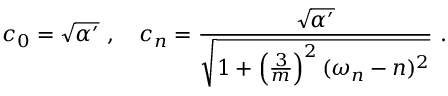<formula> <loc_0><loc_0><loc_500><loc_500>c _ { 0 } = \sqrt { \alpha ^ { \prime } } , c _ { n } = \frac { \sqrt { \alpha ^ { \prime } } } { \sqrt { 1 + \left ( \frac { 3 } { m } \right ) ^ { 2 } ( \omega _ { n } - n ) ^ { 2 } } } .</formula> 